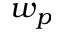Convert formula to latex. <formula><loc_0><loc_0><loc_500><loc_500>w _ { p }</formula> 